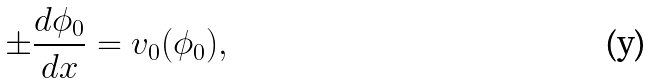Convert formula to latex. <formula><loc_0><loc_0><loc_500><loc_500>\pm \frac { d \phi _ { 0 } } { d x } = v _ { 0 } ( \phi _ { 0 } ) ,</formula> 